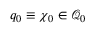Convert formula to latex. <formula><loc_0><loc_0><loc_500><loc_500>q _ { 0 } \equiv \chi _ { 0 } \in \mathcal { Q } _ { 0 }</formula> 